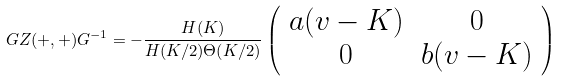Convert formula to latex. <formula><loc_0><loc_0><loc_500><loc_500>G Z ( + , + ) G ^ { - 1 } = - \frac { H ( K ) } { H ( K / 2 ) \Theta ( K / 2 ) } \left ( \begin{array} { c c } a ( v - K ) & 0 \\ 0 & b ( v - K ) \\ \end{array} \right )</formula> 